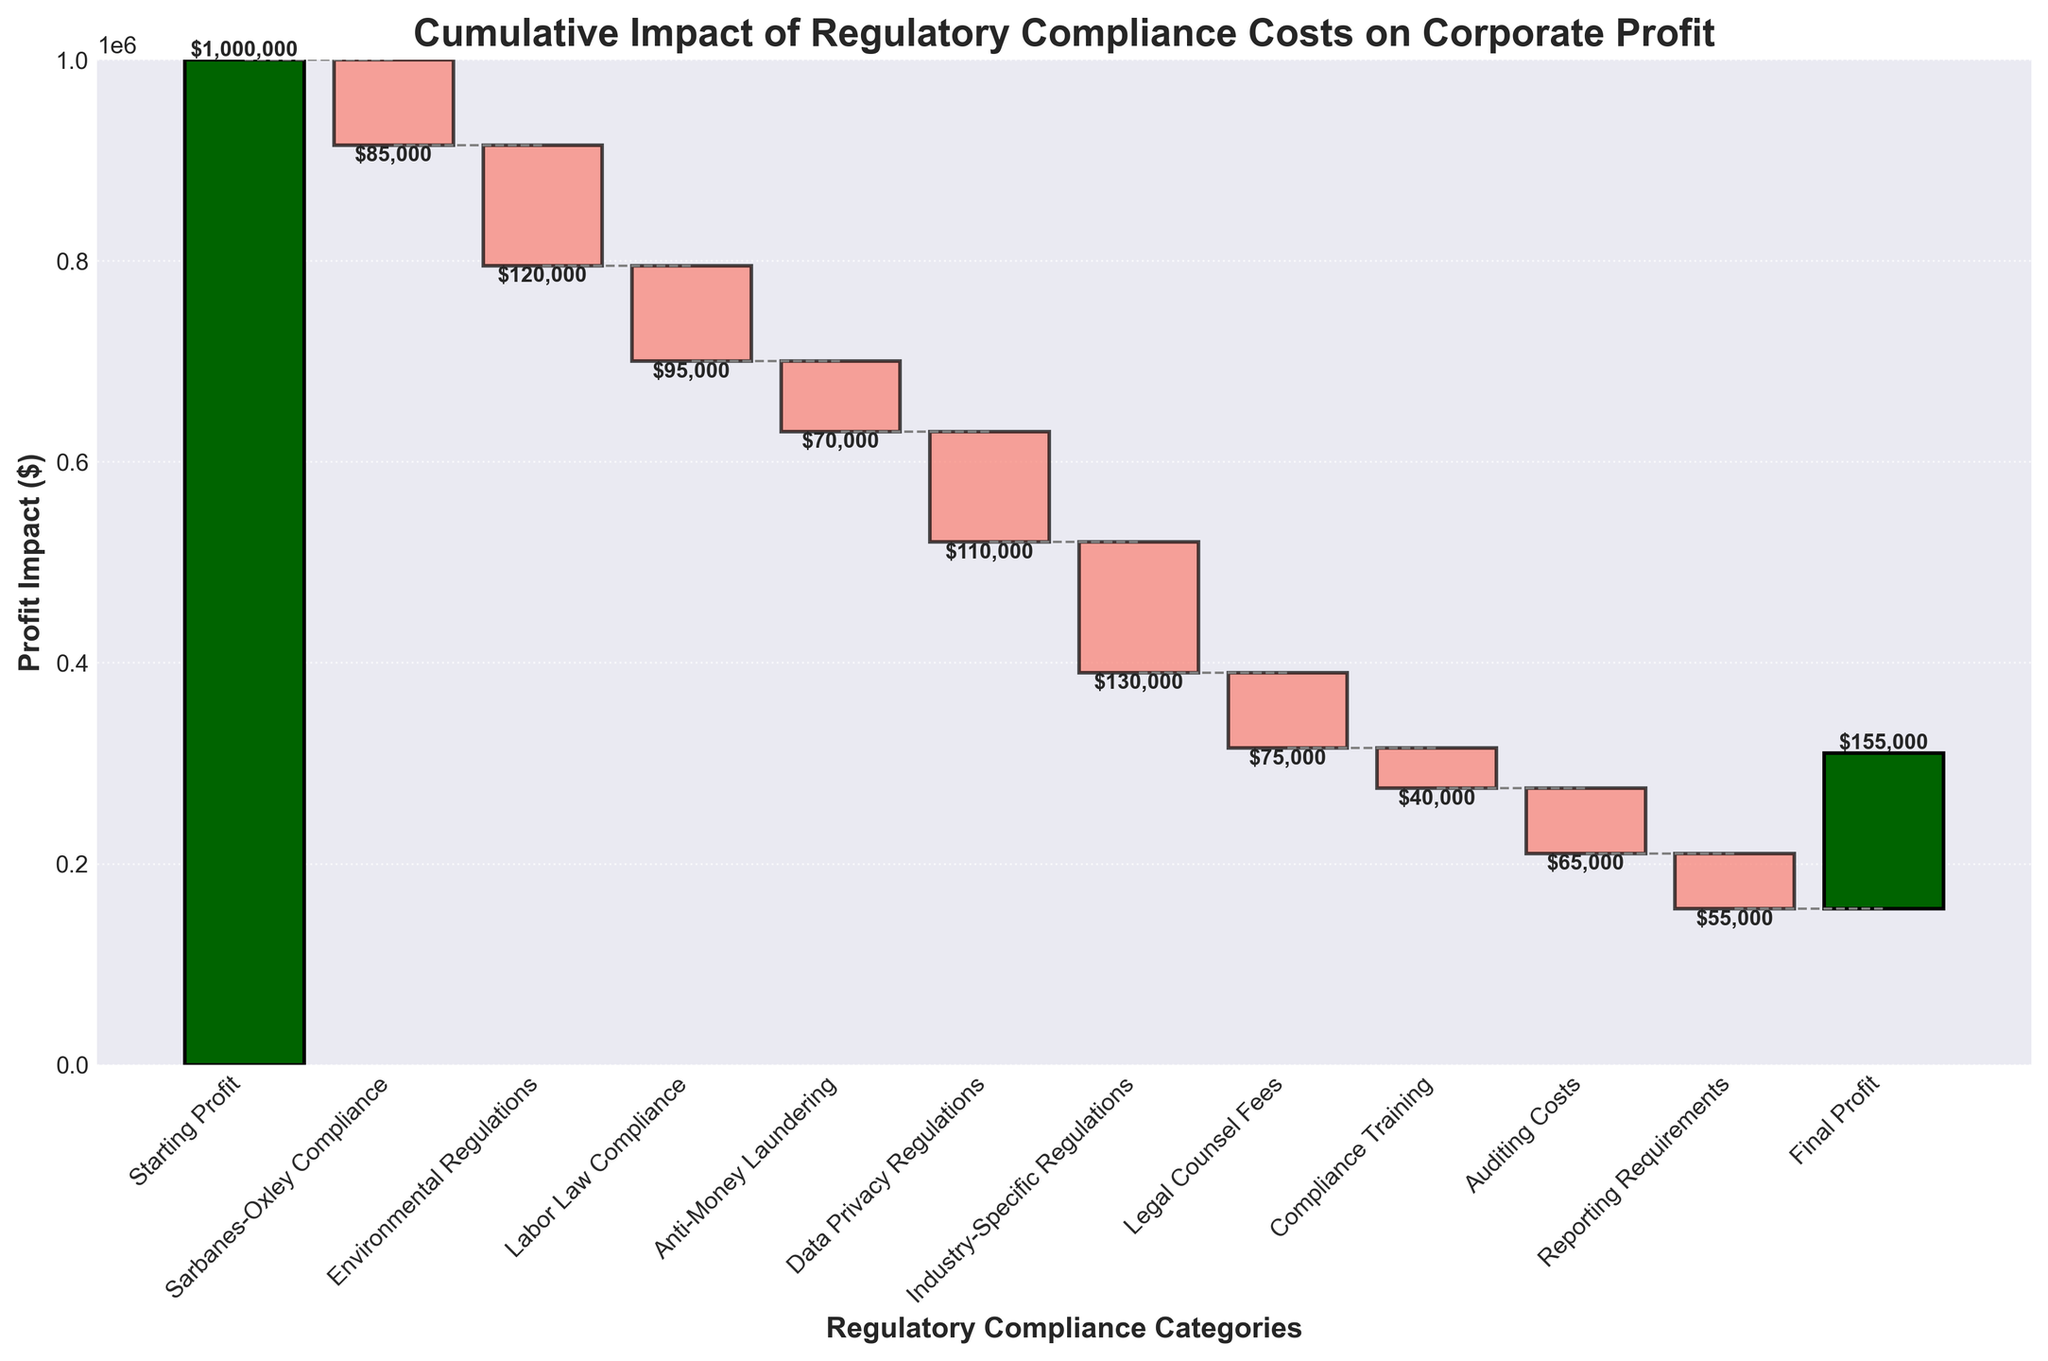What is the title of the plot? The title can be found at the top center of the plot. It reads "Cumulative Impact of Regulatory Compliance Costs on Corporate Profit."
Answer: Cumulative Impact of Regulatory Compliance Costs on Corporate Profit How is the final profit indicated in the plot? The final profit is indicated as the last bar in the series, positioned at the end of the x-axis with the label "Final Profit." The value associated with it is $155,000.
Answer: $155,000 What color indicates profit increases and what color indicates profit decreases? Profit increases are indicated by "darkgreen" and "lightgreen" colors, while profit decreases are indicated by "darkred" and "salmon" colors.
Answer: Profit increases: darkgreen/lightgreen, Profit decreases: darkred/salmon Which regulatory compliance category caused the largest decrease in profit? The category with the longest bar in the negative direction represents the largest decrease. In this case, "Industry-Specific Regulations" resulted in the largest decrease of $130,000.
Answer: Industry-Specific Regulations What is the cumulative impact on profit after accounting for "Labor Law Compliance"? Summing up the initial profit and the impacts of Sarbanes-Oxley Compliance, Environmental Regulations, and Labor Law Compliance, we get: $1,000,000 - $85,000 - $120,000 - $95,000 = $700,000.
Answer: $700,000 How much did "Compliance Training" costs impact the profits? The impact is shown as a negative bar labeled "Compliance Training" with a value of -$40,000.
Answer: $40,000 What is the total amount of profit decrease due to all regulatory compliance categories combined (excluding the starting and final profits)? Summing all values for the regulatory compliance categories: 85000 + 120000 + 95000 + 70000 + 110000 + 130000 + 75000 + 40000 + 65000 + 55000 = $785,000.
Answer: $785,000 Compare the impact of "Data Privacy Regulations" and "Legal Counsel Fees" on the profit. Which one had a larger impact and by how much? The impact of Data Privacy Regulations is -$110,000 and Legal Counsel Fees is -$75,000. The difference is calculated as $110,000 - $75,000 = $35,000. Data Privacy Regulations had a larger impact by $35,000.
Answer: Data Privacy Regulations by $35,000 What is the difference between the starting profit and the final profit? The starting profit is $1,000,000 and the final profit is $155,000. The difference is $1,000,000 - $155,000 = $845,000.
Answer: $845,000 What is the combined impact of "Auditing Costs" and "Reporting Requirements"? The sum of the impacts for Auditing Costs and Reporting Requirements is $65,000 + $55,000 = $120,000.
Answer: $120,000 